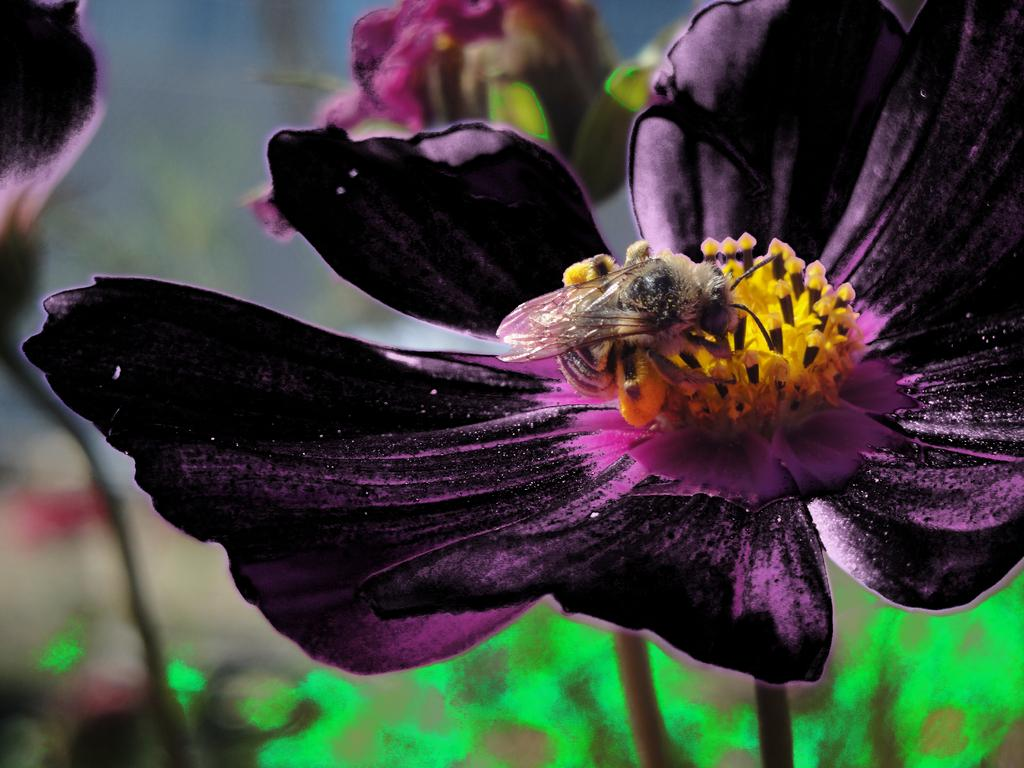What is the main subject of the image? There is a flower in the image. Can you describe the colors of the flower? The flower has purple, yellow, and black colors. Is there anything else present on the flower? Yes, there is an insect on the flower. How would you describe the background of the image? The background of the image is blurred. What type of drug is being sold by the vendor in the image? There is no vendor or drug present in the image; it features a flower with an insect on it and a blurred background. 